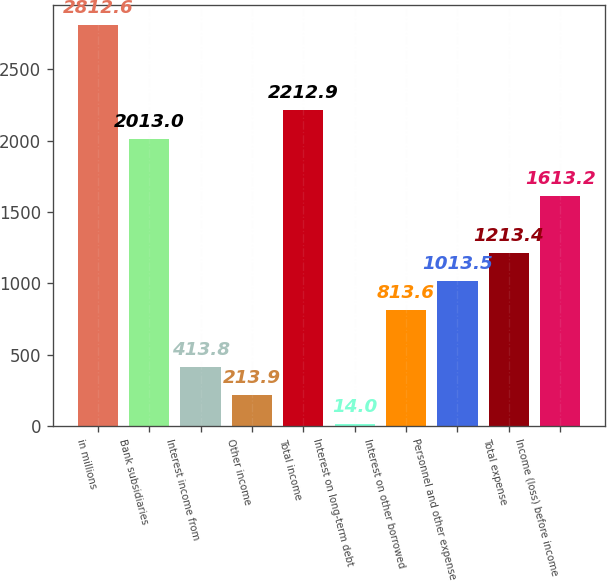<chart> <loc_0><loc_0><loc_500><loc_500><bar_chart><fcel>in millions<fcel>Bank subsidiaries<fcel>Interest income from<fcel>Other income<fcel>Total income<fcel>Interest on long-term debt<fcel>Interest on other borrowed<fcel>Personnel and other expense<fcel>Total expense<fcel>Income (loss) before income<nl><fcel>2812.6<fcel>2013<fcel>413.8<fcel>213.9<fcel>2212.9<fcel>14<fcel>813.6<fcel>1013.5<fcel>1213.4<fcel>1613.2<nl></chart> 